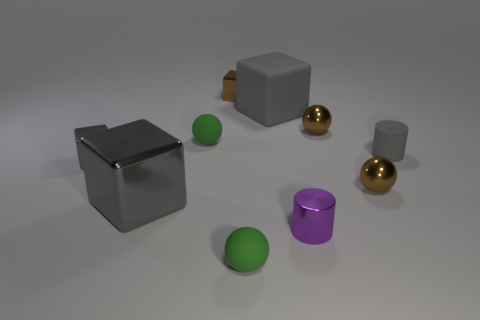How many gray blocks must be subtracted to get 1 gray blocks? 2 Subtract all yellow balls. How many gray blocks are left? 3 Subtract all spheres. How many objects are left? 6 Add 5 large gray metal objects. How many large gray metal objects are left? 6 Add 5 small blue shiny things. How many small blue shiny things exist? 5 Subtract 0 gray balls. How many objects are left? 10 Subtract all brown objects. Subtract all gray rubber cylinders. How many objects are left? 6 